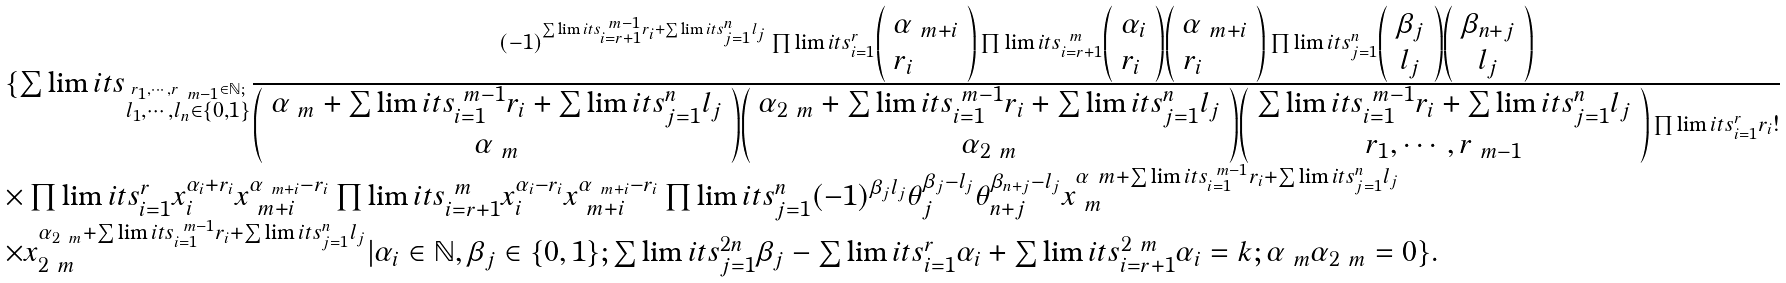<formula> <loc_0><loc_0><loc_500><loc_500>\begin{array} { l } \{ \sum \lim i t s _ { \stackrel { r _ { 1 } , \cdots , r _ { \ m - 1 } \in \mathbb { N } ; } { l _ { 1 } , \cdots , l _ { n } \in \{ 0 , 1 \} } } \frac { ( - 1 ) ^ { \sum \lim i t s _ { i = r + 1 } ^ { \ m - 1 } r _ { i } + \sum \lim i t s _ { j = 1 } ^ { n } l _ { j } } \prod \lim i t s _ { i = 1 } ^ { r } \left ( \begin{array} { l } \alpha _ { \ m + i } \\ r _ { i } \end{array} \right ) \prod \lim i t s _ { i = r + 1 } ^ { \ m } \left ( \begin{array} { l } \alpha _ { i } \\ r _ { i } \end{array} \right ) \left ( \begin{array} { l } \alpha _ { \ m + i } \\ r _ { i } \end{array} \right ) \prod \lim i t s _ { j = 1 } ^ { n } \left ( \begin{array} { c } \beta _ { j } \\ l _ { j } \end{array} \right ) \left ( \begin{array} { c } \beta _ { n + j } \\ l _ { j } \end{array} \right ) } { \left ( \begin{array} { c } \alpha _ { \ m } + \sum \lim i t s _ { i = 1 } ^ { \ m - 1 } r _ { i } + \sum \lim i t s _ { j = 1 } ^ { n } l _ { j } \\ \alpha _ { \ m } \end{array} \right ) \left ( \begin{array} { c } \alpha _ { 2 \ m } + \sum \lim i t s _ { i = 1 } ^ { \ m - 1 } r _ { i } + \sum \lim i t s _ { j = 1 } ^ { n } l _ { j } \\ \alpha _ { 2 \ m } \end{array} \right ) \left ( \begin{array} { c } \sum \lim i t s _ { i = 1 } ^ { \ m - 1 } r _ { i } + \sum \lim i t s _ { j = 1 } ^ { n } l _ { j } \\ r _ { 1 } , \cdots , r _ { \ m - 1 } \end{array} \right ) \prod \lim i t s _ { i = 1 } ^ { r } r _ { i } ! } \\ \times \prod \lim i t s _ { i = 1 } ^ { r } x _ { i } ^ { \alpha _ { i } + r _ { i } } x _ { \ m + i } ^ { \alpha _ { \ m + i } - r _ { i } } \prod \lim i t s _ { i = r + 1 } ^ { \ m } x _ { i } ^ { \alpha _ { i } - r _ { i } } x _ { \ m + i } ^ { \alpha _ { \ m + i } - r _ { i } } \prod \lim i t s _ { j = 1 } ^ { n } ( - 1 ) ^ { \beta _ { j } l _ { j } } \theta _ { j } ^ { \beta _ { j } - l _ { j } } \theta _ { n + j } ^ { \beta _ { n + j } - l _ { j } } x _ { \ m } ^ { \alpha _ { \ } m + \sum \lim i t s _ { i = 1 } ^ { \ m - 1 } r _ { i } + \sum \lim i t s _ { j = 1 } ^ { n } l _ { j } } \\ \times x _ { 2 \ m } ^ { \alpha _ { 2 \ m } + \sum \lim i t s _ { i = 1 } ^ { \ m - 1 } r _ { i } + \sum \lim i t s _ { j = 1 } ^ { n } l _ { j } } | \alpha _ { i } \in \mathbb { N } , \beta _ { j } \in \{ 0 , 1 \} ; \sum \lim i t s _ { j = 1 } ^ { 2 n } \beta _ { j } - \sum \lim i t s _ { i = 1 } ^ { r } \alpha _ { i } + \sum \lim i t s _ { i = r + 1 } ^ { 2 \ m } \alpha _ { i } = k ; \alpha _ { \ m } \alpha _ { 2 \ m } = 0 \} . \end{array}</formula> 